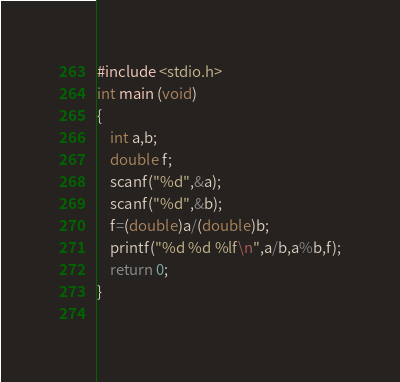Convert code to text. <code><loc_0><loc_0><loc_500><loc_500><_C_>#include <stdio.h>
int main (void)
{
	int a,b;
	double f;
	scanf("%d",&a);
	scanf("%d",&b);
	f=(double)a/(double)b;
	printf("%d %d %lf\n",a/b,a%b,f);
	return 0;
}
 </code> 